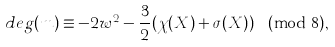<formula> <loc_0><loc_0><loc_500><loc_500>d e g ( m ) \equiv - 2 w ^ { 2 } - \frac { 3 } { 2 } ( \chi ( X ) + \sigma ( X ) ) \pmod { 8 } ,</formula> 